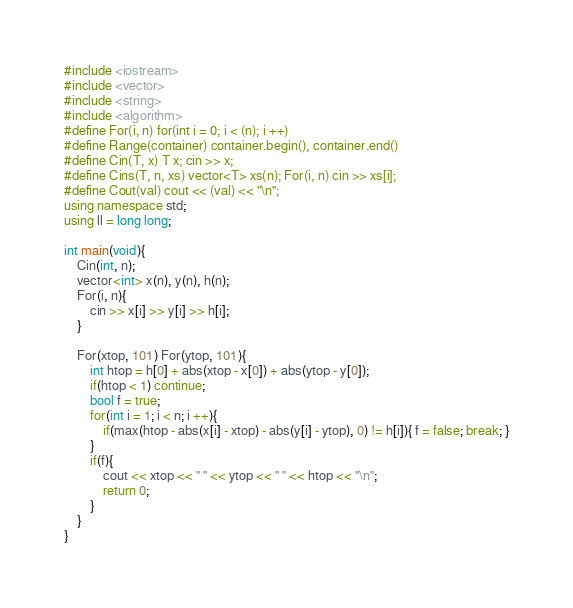Convert code to text. <code><loc_0><loc_0><loc_500><loc_500><_C++_>#include <iostream>
#include <vector>
#include <string>
#include <algorithm>
#define For(i, n) for(int i = 0; i < (n); i ++)
#define Range(container) container.begin(), container.end()
#define Cin(T, x) T x; cin >> x;
#define Cins(T, n, xs) vector<T> xs(n); For(i, n) cin >> xs[i];
#define Cout(val) cout << (val) << "\n";
using namespace std;
using ll = long long;

int main(void){
    Cin(int, n);
    vector<int> x(n), y(n), h(n);
    For(i, n){
        cin >> x[i] >> y[i] >> h[i];
    }
    
    For(xtop, 101) For(ytop, 101){
        int htop = h[0] + abs(xtop - x[0]) + abs(ytop - y[0]);
        if(htop < 1) continue;
        bool f = true;
        for(int i = 1; i < n; i ++){
            if(max(htop - abs(x[i] - xtop) - abs(y[i] - ytop), 0) != h[i]){ f = false; break; }
        }
        if(f){
            cout << xtop << " " << ytop << " " << htop << "\n";
            return 0;
        }
    }
}
</code> 